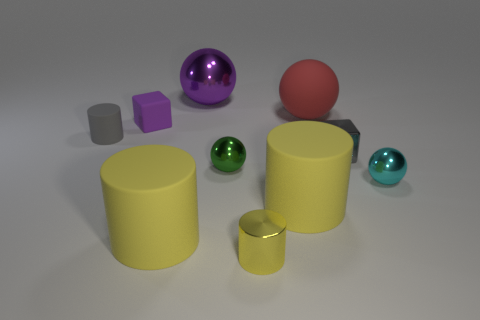How many other things are there of the same color as the small matte cylinder?
Give a very brief answer. 1. Does the purple sphere have the same material as the tiny cylinder that is in front of the cyan ball?
Your answer should be very brief. Yes. There is a yellow cylinder in front of the yellow matte cylinder that is left of the tiny yellow thing; what number of large yellow objects are on the left side of it?
Keep it short and to the point. 1. Are there fewer small gray metal things that are to the left of the small gray block than gray matte cylinders that are in front of the small metal cylinder?
Offer a terse response. No. How many other things are there of the same material as the gray cube?
Offer a very short reply. 4. What material is the purple object that is the same size as the red ball?
Offer a terse response. Metal. How many purple things are either large balls or metal cylinders?
Offer a very short reply. 1. The shiny sphere that is in front of the tiny gray block and on the left side of the tiny gray cube is what color?
Provide a succinct answer. Green. Does the small cube in front of the purple rubber thing have the same material as the small cylinder right of the small gray cylinder?
Offer a terse response. Yes. Are there more cyan shiny objects that are left of the small purple object than tiny gray cubes left of the tiny gray block?
Provide a short and direct response. No. 